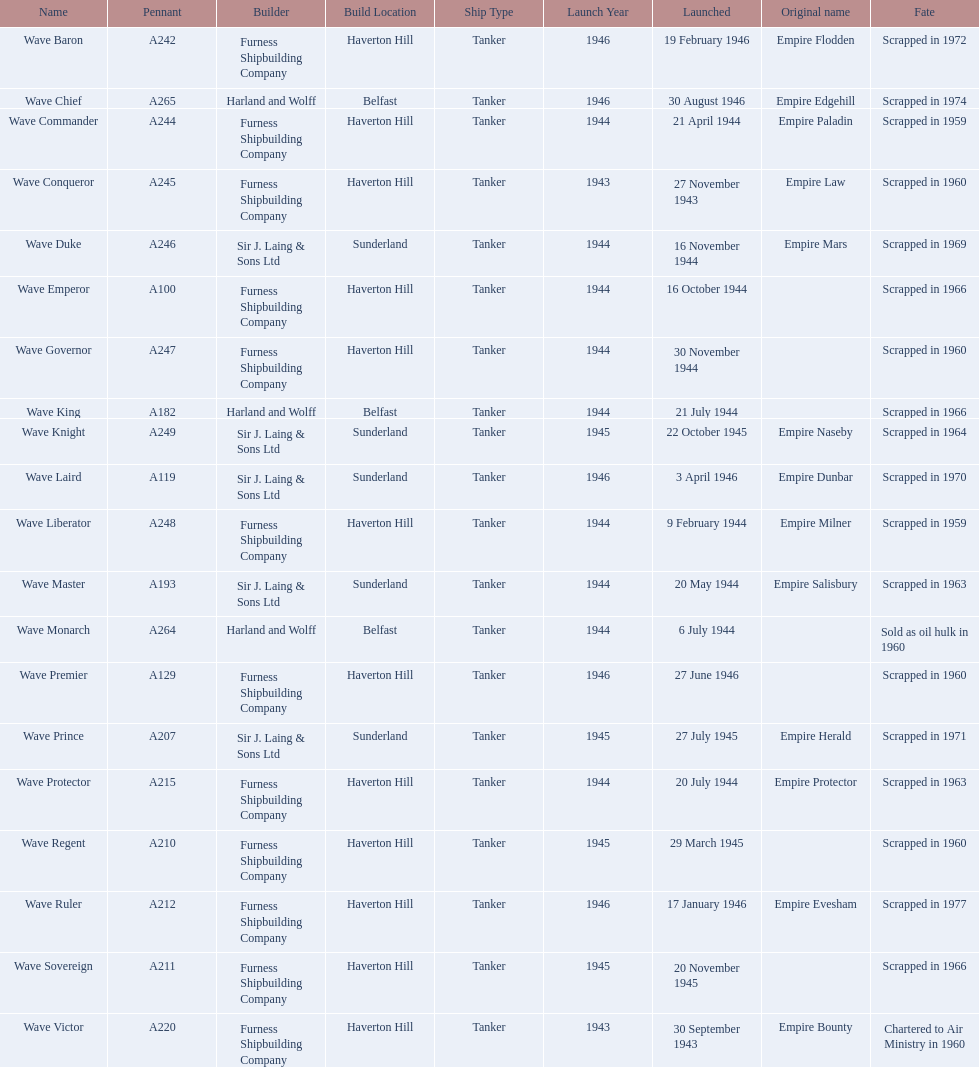What was the date of the first ship's initial launch? 30 September 1943. 